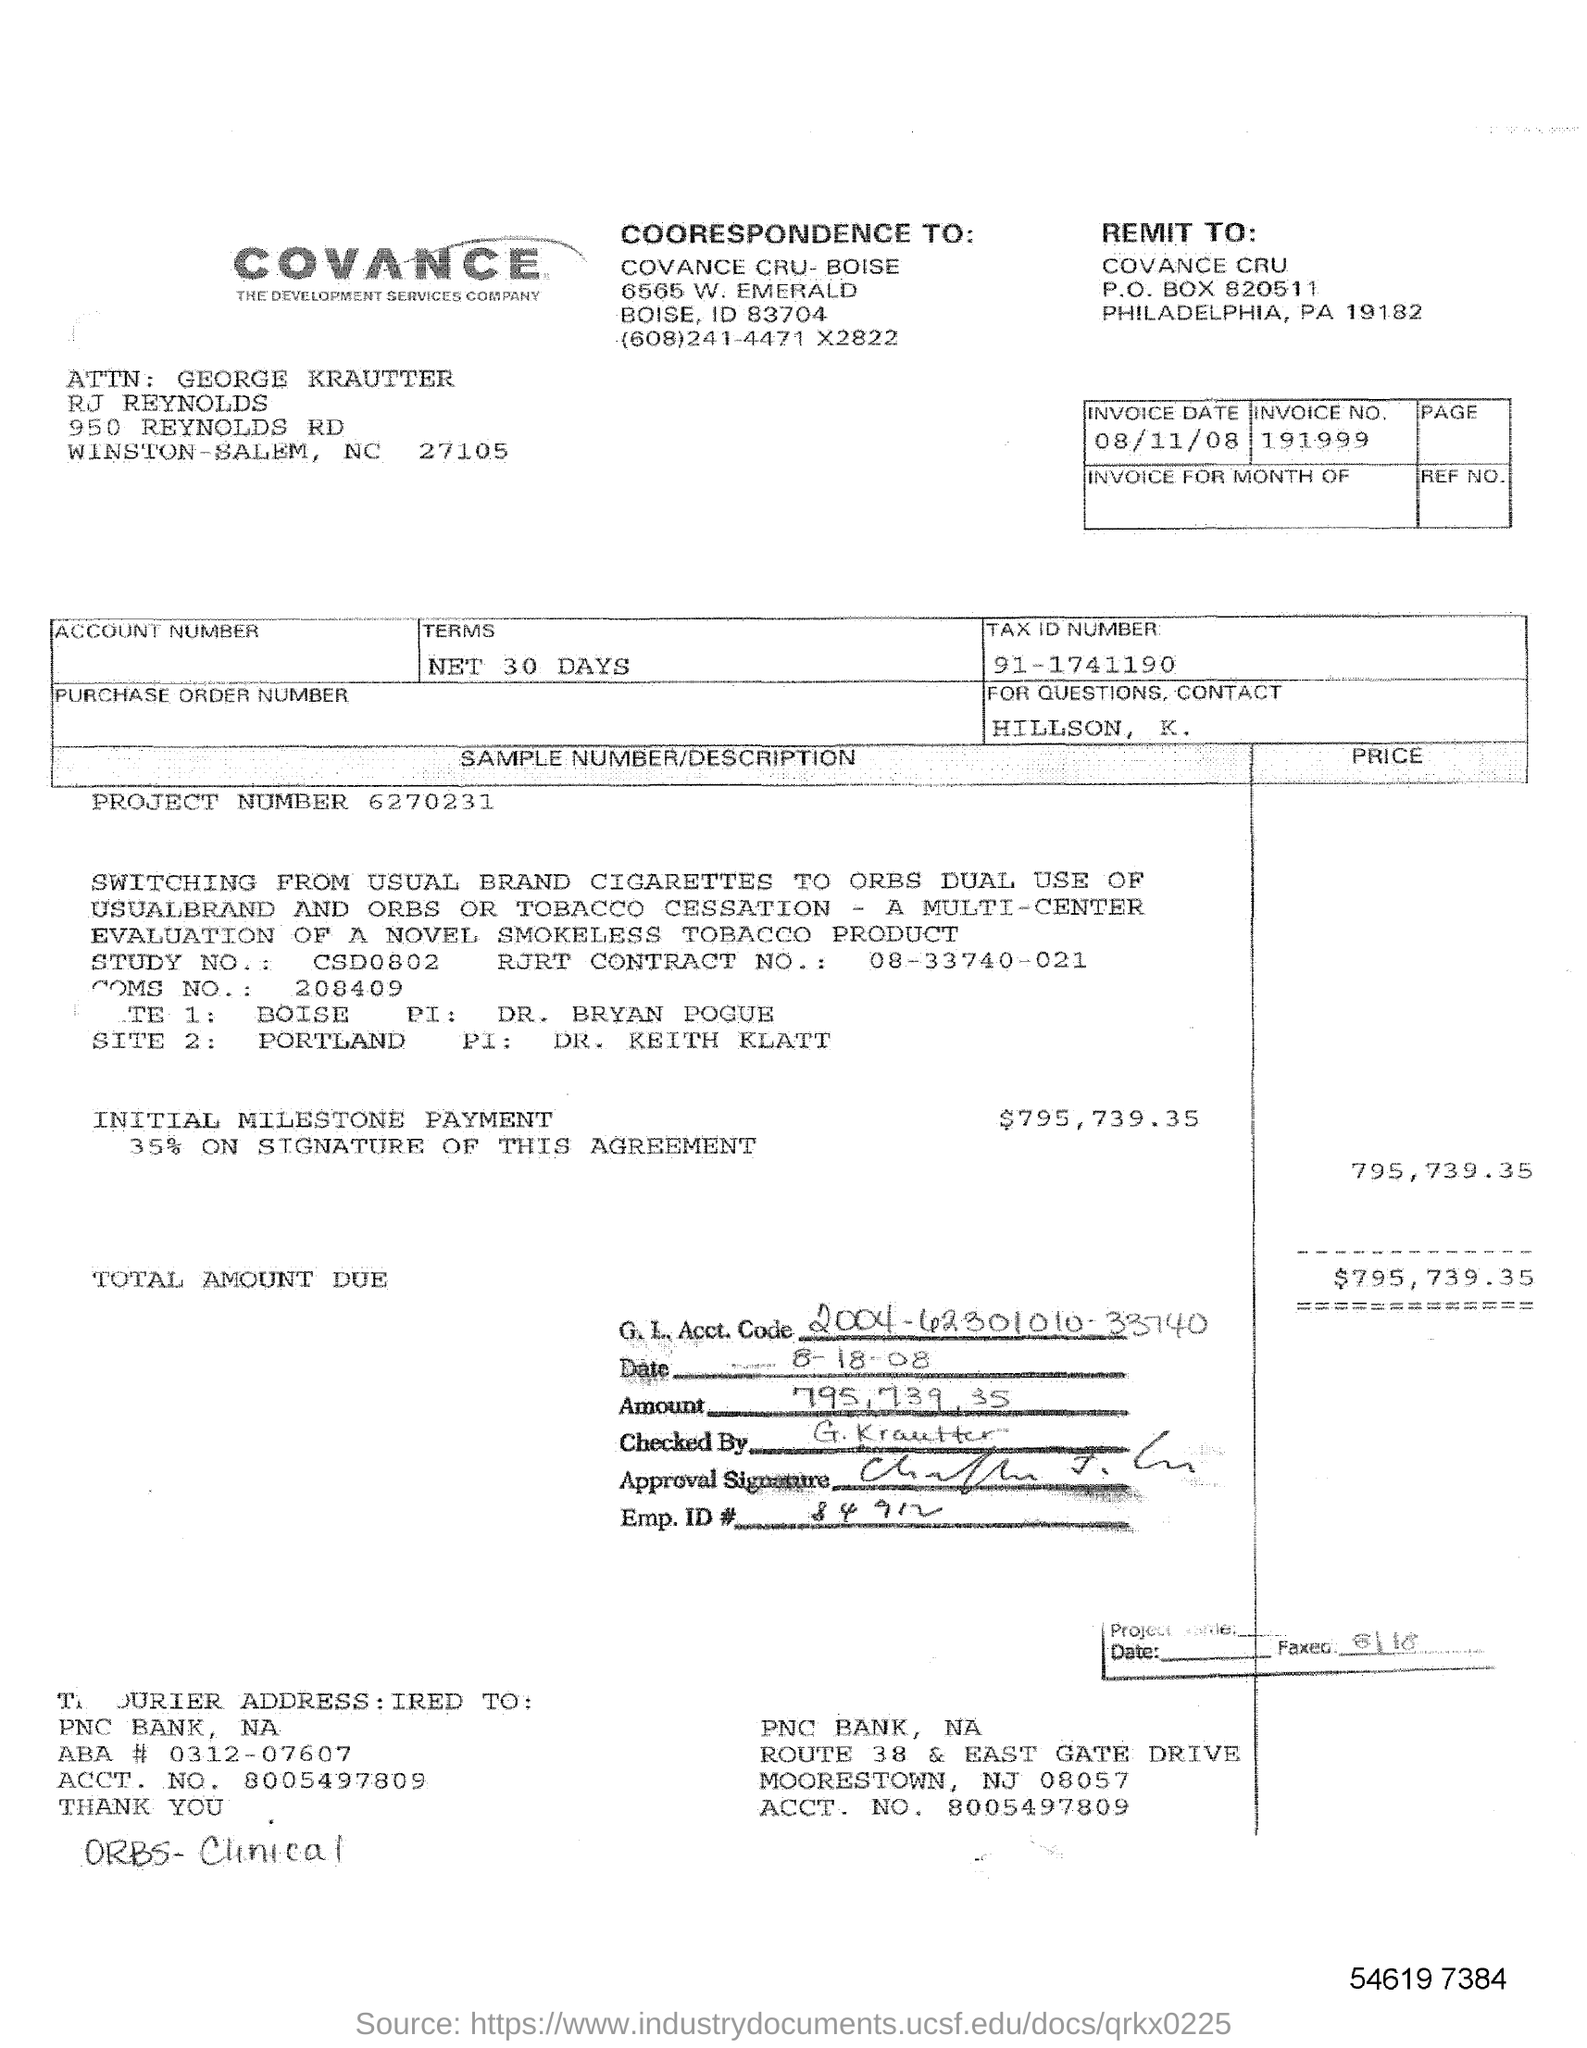Outline some significant characteristics in this image. The initial milestone payment is $795,739.35. The date on the bill invoice is August 11, 2008. If there are any inquiries, please contact HILLSON, K... The invoice number is 191999... 